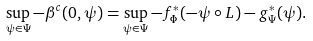Convert formula to latex. <formula><loc_0><loc_0><loc_500><loc_500>\sup _ { \psi \in \Psi } - \beta ^ { c } ( 0 , \psi ) = \sup _ { \psi \in \Psi } - f ^ { * } _ { \Phi } ( - \psi \circ L ) - g ^ { * } _ { \Psi } ( \psi ) .</formula> 